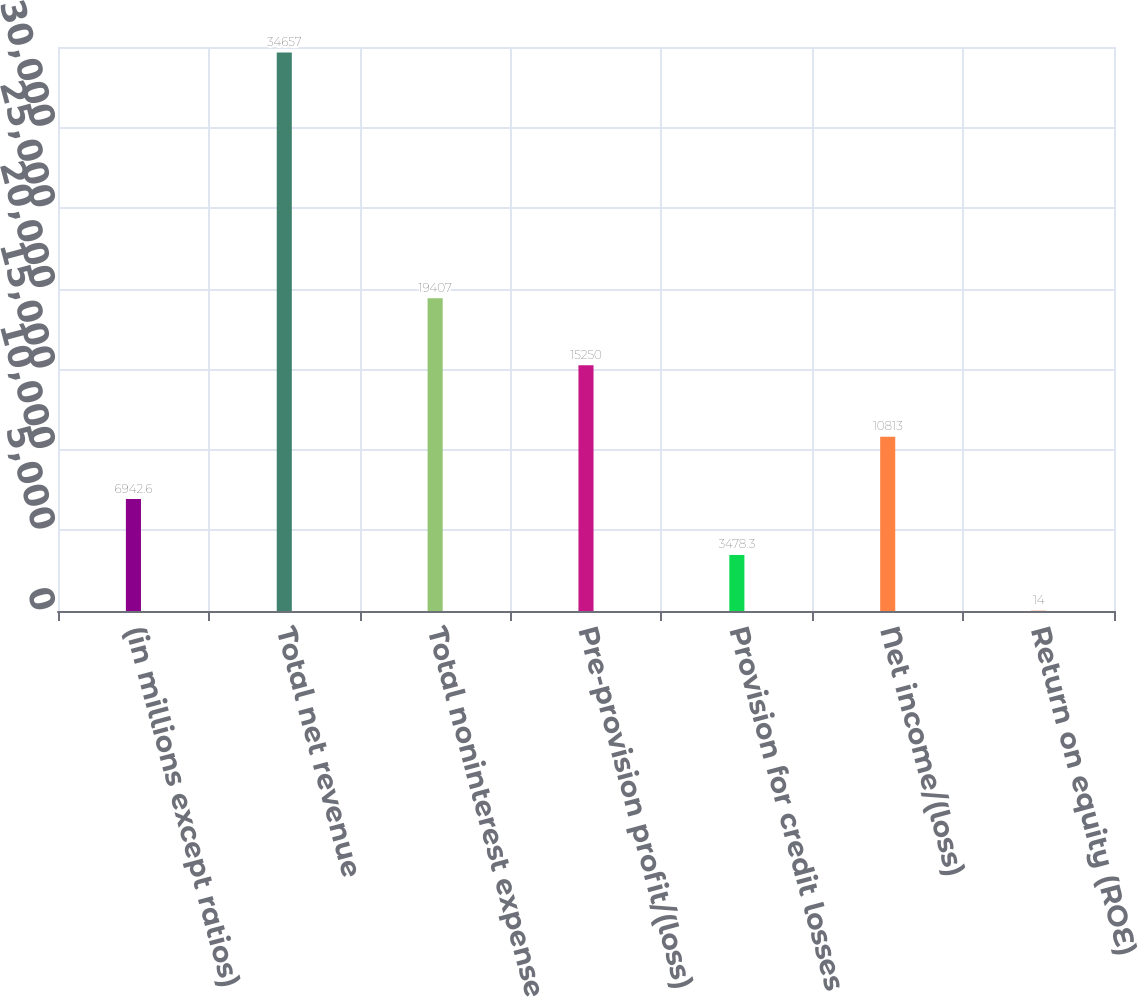<chart> <loc_0><loc_0><loc_500><loc_500><bar_chart><fcel>(in millions except ratios)<fcel>Total net revenue<fcel>Total noninterest expense<fcel>Pre-provision profit/(loss)<fcel>Provision for credit losses<fcel>Net income/(loss)<fcel>Return on equity (ROE)<nl><fcel>6942.6<fcel>34657<fcel>19407<fcel>15250<fcel>3478.3<fcel>10813<fcel>14<nl></chart> 